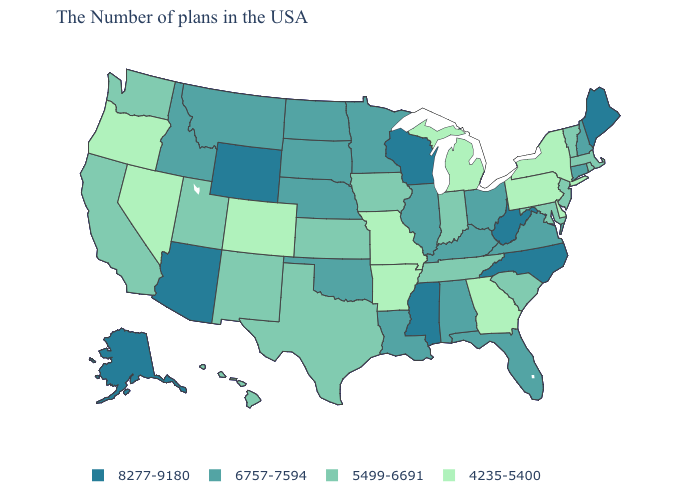What is the value of Connecticut?
Concise answer only. 6757-7594. Does West Virginia have the highest value in the USA?
Short answer required. Yes. What is the value of Rhode Island?
Be succinct. 5499-6691. What is the value of West Virginia?
Concise answer only. 8277-9180. Which states have the lowest value in the USA?
Be succinct. New York, Delaware, Pennsylvania, Georgia, Michigan, Missouri, Arkansas, Colorado, Nevada, Oregon. What is the value of Delaware?
Give a very brief answer. 4235-5400. Among the states that border New Jersey , which have the highest value?
Write a very short answer. New York, Delaware, Pennsylvania. What is the highest value in states that border North Carolina?
Short answer required. 6757-7594. Among the states that border Iowa , does Illinois have the lowest value?
Answer briefly. No. Name the states that have a value in the range 6757-7594?
Give a very brief answer. New Hampshire, Connecticut, Virginia, Ohio, Florida, Kentucky, Alabama, Illinois, Louisiana, Minnesota, Nebraska, Oklahoma, South Dakota, North Dakota, Montana, Idaho. Name the states that have a value in the range 5499-6691?
Write a very short answer. Massachusetts, Rhode Island, Vermont, New Jersey, Maryland, South Carolina, Indiana, Tennessee, Iowa, Kansas, Texas, New Mexico, Utah, California, Washington, Hawaii. What is the highest value in the South ?
Give a very brief answer. 8277-9180. Does Vermont have the lowest value in the Northeast?
Keep it brief. No. What is the lowest value in the USA?
Be succinct. 4235-5400. What is the highest value in the USA?
Keep it brief. 8277-9180. 